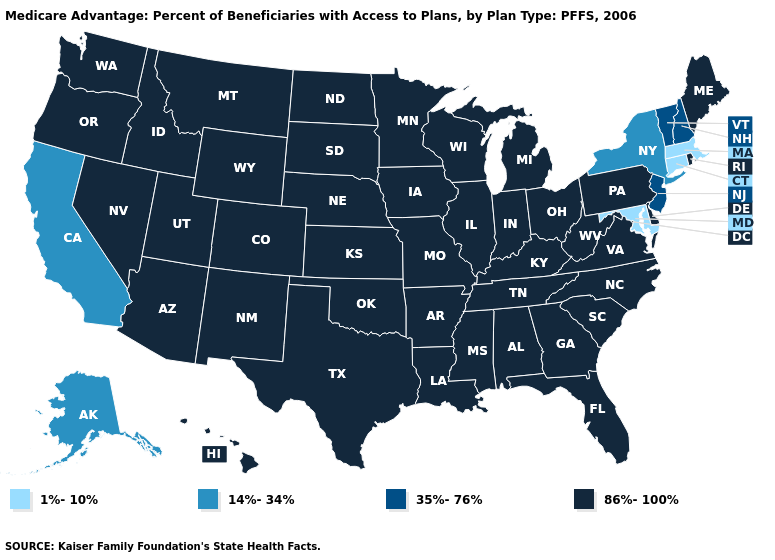Does the map have missing data?
Be succinct. No. Name the states that have a value in the range 14%-34%?
Keep it brief. Alaska, California, New York. Among the states that border New Jersey , which have the highest value?
Give a very brief answer. Delaware, Pennsylvania. Which states hav the highest value in the South?
Short answer required. Alabama, Arkansas, Delaware, Florida, Georgia, Kentucky, Louisiana, Mississippi, North Carolina, Oklahoma, South Carolina, Tennessee, Texas, Virginia, West Virginia. What is the highest value in the Northeast ?
Quick response, please. 86%-100%. Does California have the lowest value in the West?
Write a very short answer. Yes. Does Maryland have the highest value in the South?
Write a very short answer. No. Name the states that have a value in the range 35%-76%?
Keep it brief. New Hampshire, New Jersey, Vermont. Among the states that border New Jersey , does Pennsylvania have the lowest value?
Give a very brief answer. No. What is the highest value in the USA?
Concise answer only. 86%-100%. What is the highest value in states that border California?
Quick response, please. 86%-100%. What is the lowest value in the Northeast?
Keep it brief. 1%-10%. What is the value of Tennessee?
Quick response, please. 86%-100%. What is the highest value in the USA?
Quick response, please. 86%-100%. 